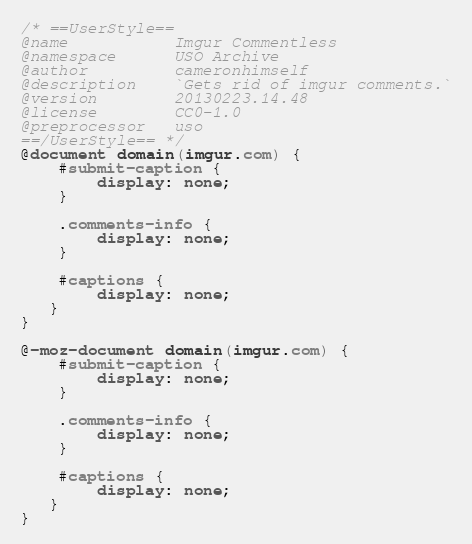Convert code to text. <code><loc_0><loc_0><loc_500><loc_500><_CSS_>/* ==UserStyle==
@name           Imgur Commentless
@namespace      USO Archive
@author         cameronhimself
@description    `Gets rid of imgur comments.`
@version        20130223.14.48
@license        CC0-1.0
@preprocessor   uso
==/UserStyle== */
@document domain(imgur.com) {
    #submit-caption {
        display: none;
    }
    
    .comments-info {
        display: none;
    }
    
    #captions {
        display: none;
   }
}

@-moz-document domain(imgur.com) {
    #submit-caption {
        display: none;
    }
    
    .comments-info {
        display: none;
    }
    
    #captions {
        display: none;
   }
}</code> 